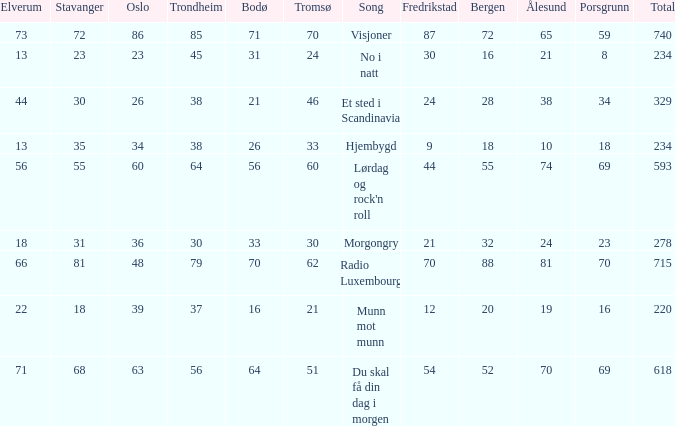Can you give me this table as a dict? {'header': ['Elverum', 'Stavanger', 'Oslo', 'Trondheim', 'Bodø', 'Tromsø', 'Song', 'Fredrikstad', 'Bergen', 'Ålesund', 'Porsgrunn', 'Total'], 'rows': [['73', '72', '86', '85', '71', '70', 'Visjoner', '87', '72', '65', '59', '740'], ['13', '23', '23', '45', '31', '24', 'No i natt', '30', '16', '21', '8', '234'], ['44', '30', '26', '38', '21', '46', 'Et sted i Scandinavia', '24', '28', '38', '34', '329'], ['13', '35', '34', '38', '26', '33', 'Hjembygd', '9', '18', '10', '18', '234'], ['56', '55', '60', '64', '56', '60', "Lørdag og rock'n roll", '44', '55', '74', '69', '593'], ['18', '31', '36', '30', '33', '30', 'Morgongry', '21', '32', '24', '23', '278'], ['66', '81', '48', '79', '70', '62', 'Radio Luxembourg', '70', '88', '81', '70', '715'], ['22', '18', '39', '37', '16', '21', 'Munn mot munn', '12', '20', '19', '16', '220'], ['71', '68', '63', '56', '64', '51', 'Du skal få din dag i morgen', '54', '52', '70', '69', '618']]} What is the lowest total? 220.0. 